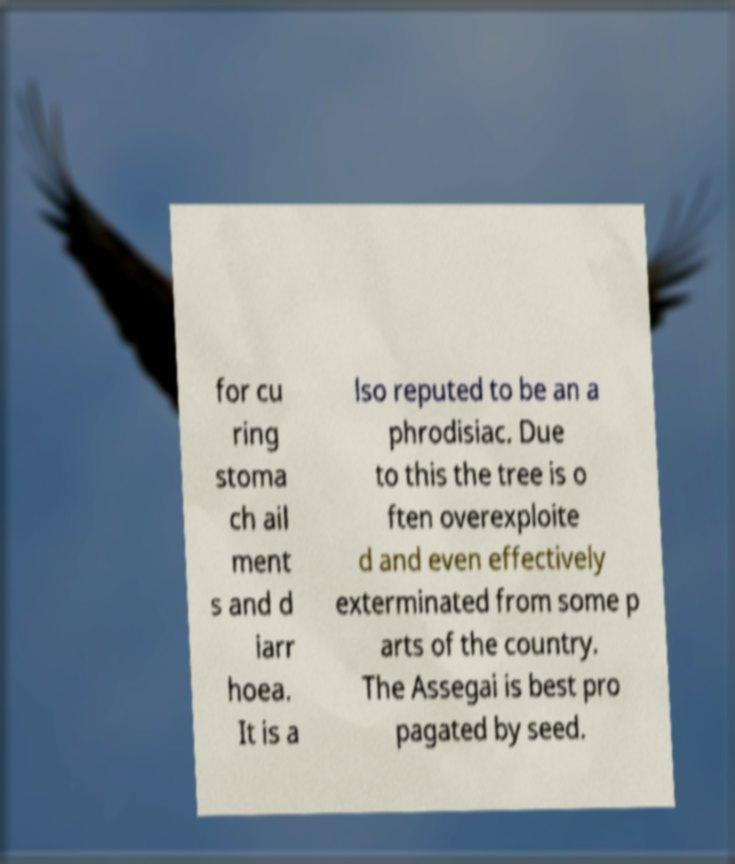Could you assist in decoding the text presented in this image and type it out clearly? for cu ring stoma ch ail ment s and d iarr hoea. It is a lso reputed to be an a phrodisiac. Due to this the tree is o ften overexploite d and even effectively exterminated from some p arts of the country. The Assegai is best pro pagated by seed. 